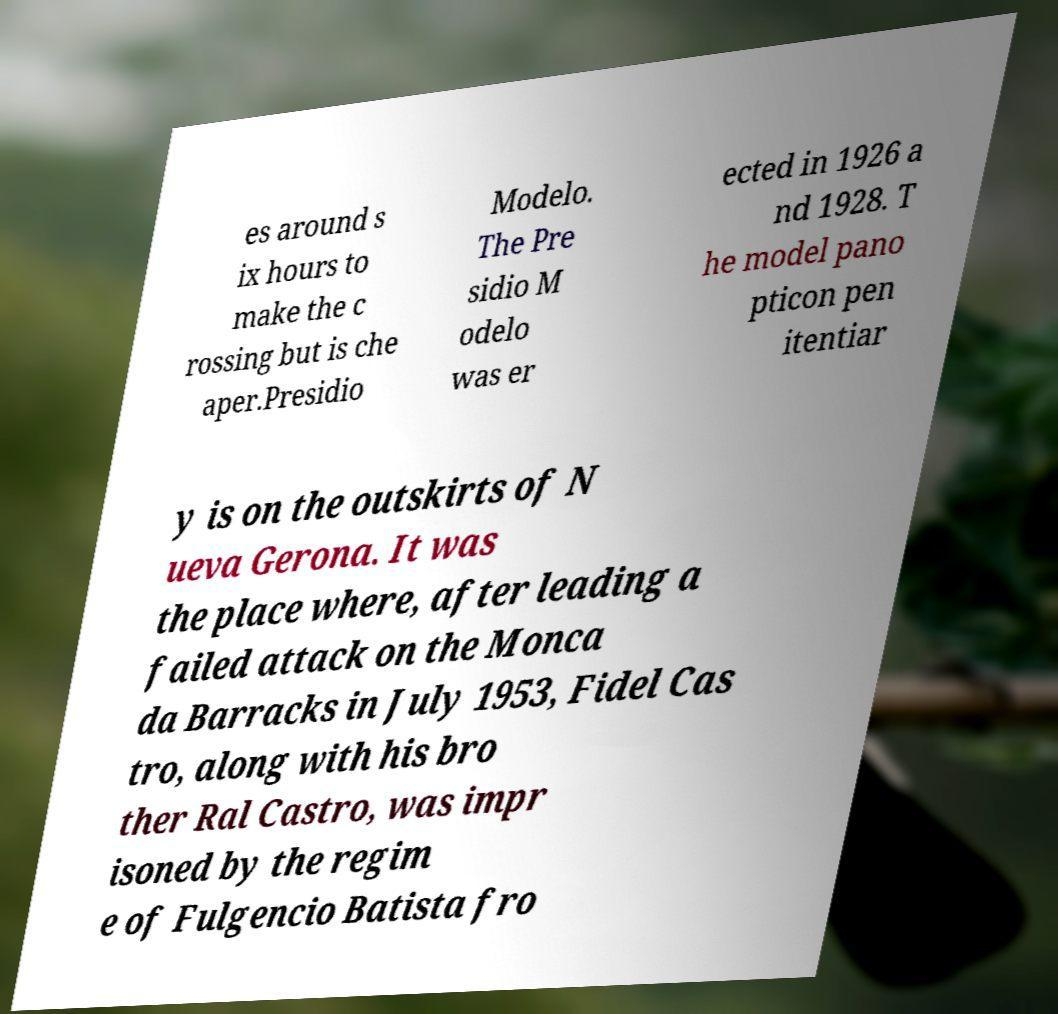There's text embedded in this image that I need extracted. Can you transcribe it verbatim? es around s ix hours to make the c rossing but is che aper.Presidio Modelo. The Pre sidio M odelo was er ected in 1926 a nd 1928. T he model pano pticon pen itentiar y is on the outskirts of N ueva Gerona. It was the place where, after leading a failed attack on the Monca da Barracks in July 1953, Fidel Cas tro, along with his bro ther Ral Castro, was impr isoned by the regim e of Fulgencio Batista fro 